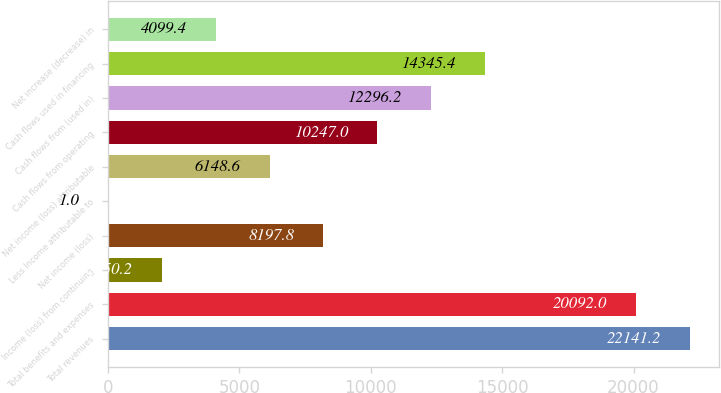Convert chart. <chart><loc_0><loc_0><loc_500><loc_500><bar_chart><fcel>Total revenues<fcel>Total benefits and expenses<fcel>Income (loss) from continuing<fcel>Net income (loss)<fcel>Less Income attributable to<fcel>Net income (loss) attributable<fcel>Cash flows from operating<fcel>Cash flows from (used in)<fcel>Cash flows used in financing<fcel>Net increase (decrease) in<nl><fcel>22141.2<fcel>20092<fcel>2050.2<fcel>8197.8<fcel>1<fcel>6148.6<fcel>10247<fcel>12296.2<fcel>14345.4<fcel>4099.4<nl></chart> 